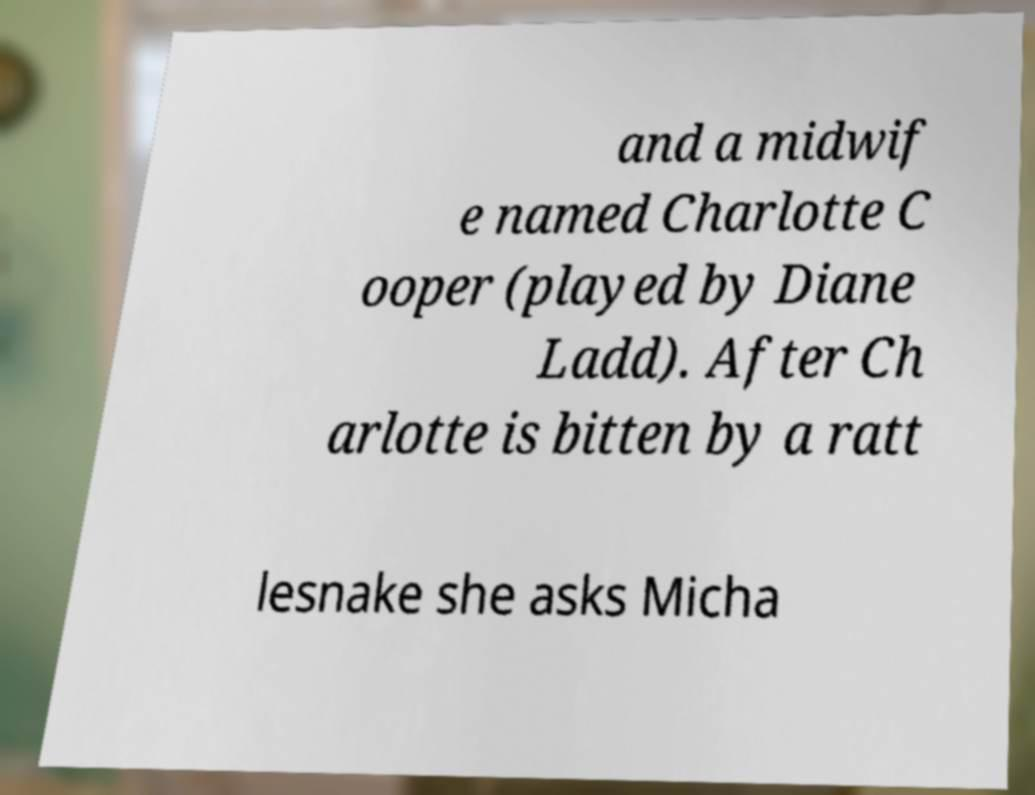I need the written content from this picture converted into text. Can you do that? and a midwif e named Charlotte C ooper (played by Diane Ladd). After Ch arlotte is bitten by a ratt lesnake she asks Micha 